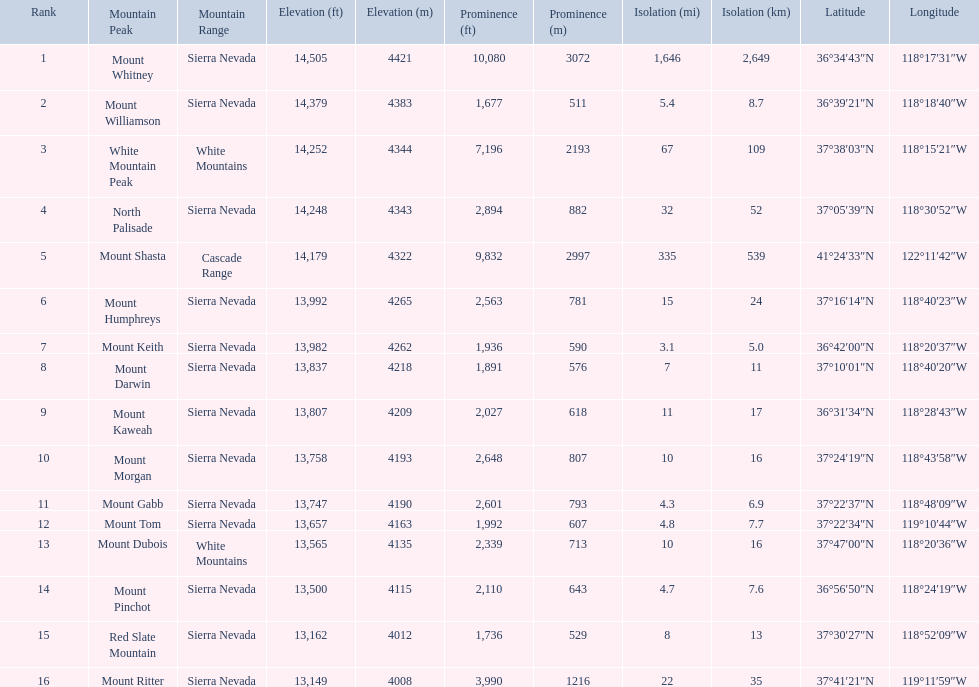Which are the mountain peaks? Mount Whitney, Mount Williamson, White Mountain Peak, North Palisade, Mount Shasta, Mount Humphreys, Mount Keith, Mount Darwin, Mount Kaweah, Mount Morgan, Mount Gabb, Mount Tom, Mount Dubois, Mount Pinchot, Red Slate Mountain, Mount Ritter. Of these, which is in the cascade range? Mount Shasta. 